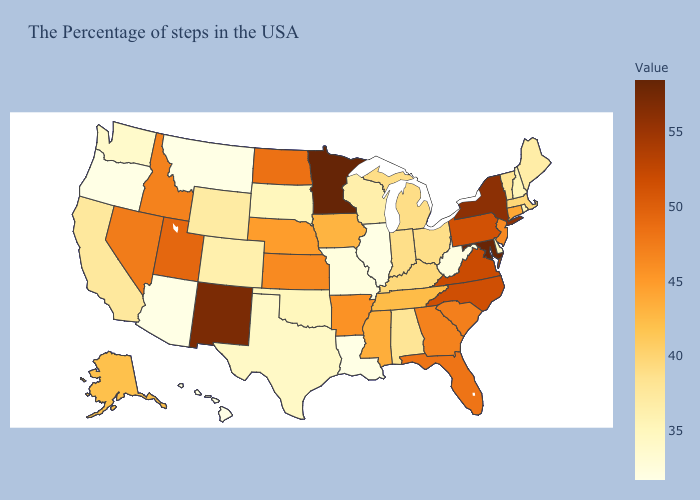Among the states that border Indiana , does Kentucky have the highest value?
Short answer required. Yes. Does Maryland have the highest value in the South?
Answer briefly. Yes. Among the states that border Illinois , which have the highest value?
Write a very short answer. Iowa. Does Colorado have the lowest value in the West?
Quick response, please. No. Among the states that border Georgia , which have the lowest value?
Answer briefly. Alabama. Does Indiana have a lower value than South Dakota?
Short answer required. No. 